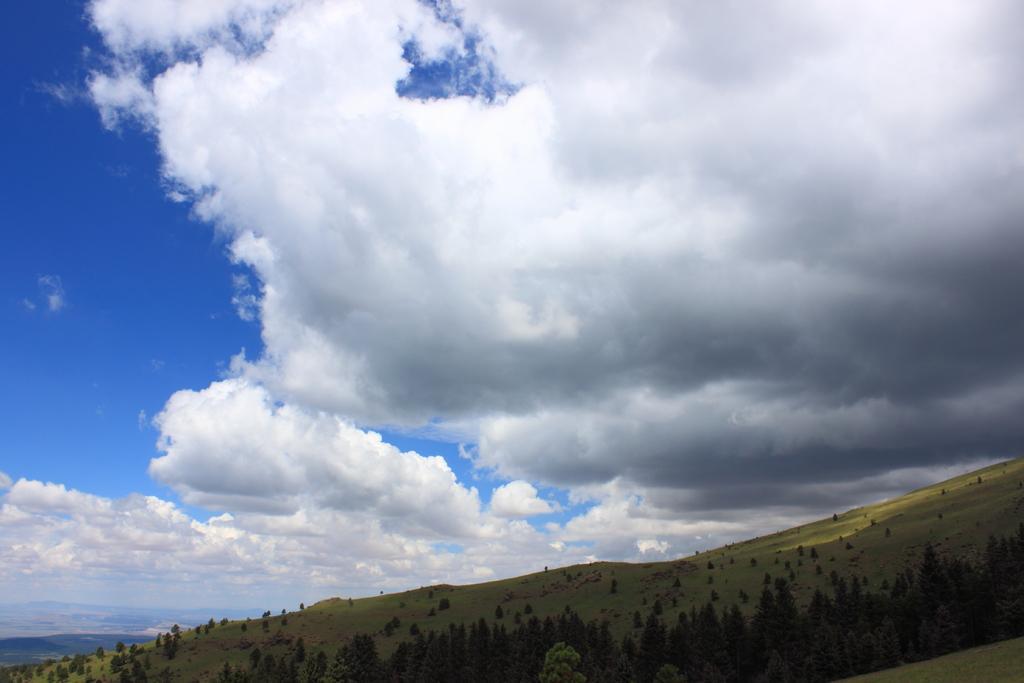Please provide a concise description of this image. In this image I can see the trees on the ground. In the background I can see the clouds and the blue sky. 